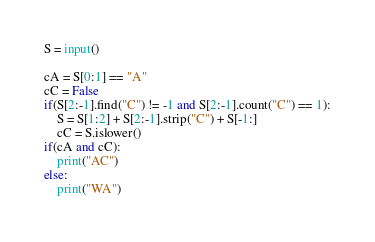<code> <loc_0><loc_0><loc_500><loc_500><_Python_>S = input()

cA = S[0:1] == "A"
cC = False
if(S[2:-1].find("C") != -1 and S[2:-1].count("C") == 1):
    S = S[1:2] + S[2:-1].strip("C") + S[-1:]
    cC = S.islower()
if(cA and cC):
    print("AC")
else:
    print("WA")</code> 